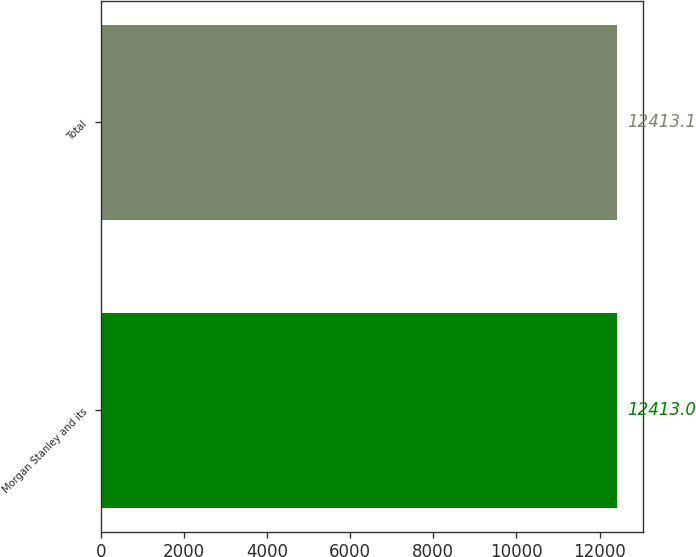Convert chart to OTSL. <chart><loc_0><loc_0><loc_500><loc_500><bar_chart><fcel>Morgan Stanley and its<fcel>Total<nl><fcel>12413<fcel>12413.1<nl></chart> 